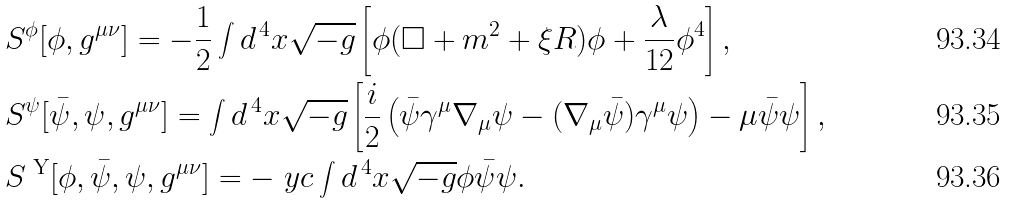<formula> <loc_0><loc_0><loc_500><loc_500>& S ^ { \phi } [ \phi , g ^ { \mu \nu } ] = - \frac { 1 } { 2 } \int d ^ { \, 4 } x \sqrt { - g } \left [ \phi ( \square + m ^ { 2 } + \xi R ) \phi + \frac { \lambda } { 1 2 } \phi ^ { 4 } \right ] , \\ & S ^ { \psi } [ \bar { \psi } , \psi , g ^ { \mu \nu } ] = \int d ^ { \, 4 } x \sqrt { - g } \left [ \frac { i } { 2 } \left ( \bar { \psi } \gamma ^ { \mu } \nabla _ { \mu } \psi - ( \nabla _ { \mu } \bar { \psi } ) \gamma ^ { \mu } \psi \right ) - \mu \bar { \psi } \psi \right ] , \\ & S ^ { \text { Y} } [ \phi , \bar { \psi } , \psi , g ^ { \mu \nu } ] = - \ y c \int d ^ { \, 4 } x \sqrt { - g } \phi \bar { \psi } \psi .</formula> 